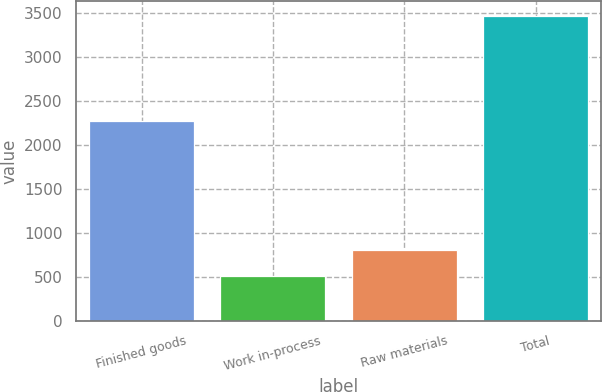<chart> <loc_0><loc_0><loc_500><loc_500><bar_chart><fcel>Finished goods<fcel>Work in-process<fcel>Raw materials<fcel>Total<nl><fcel>2268<fcel>509<fcel>804.4<fcel>3463<nl></chart> 